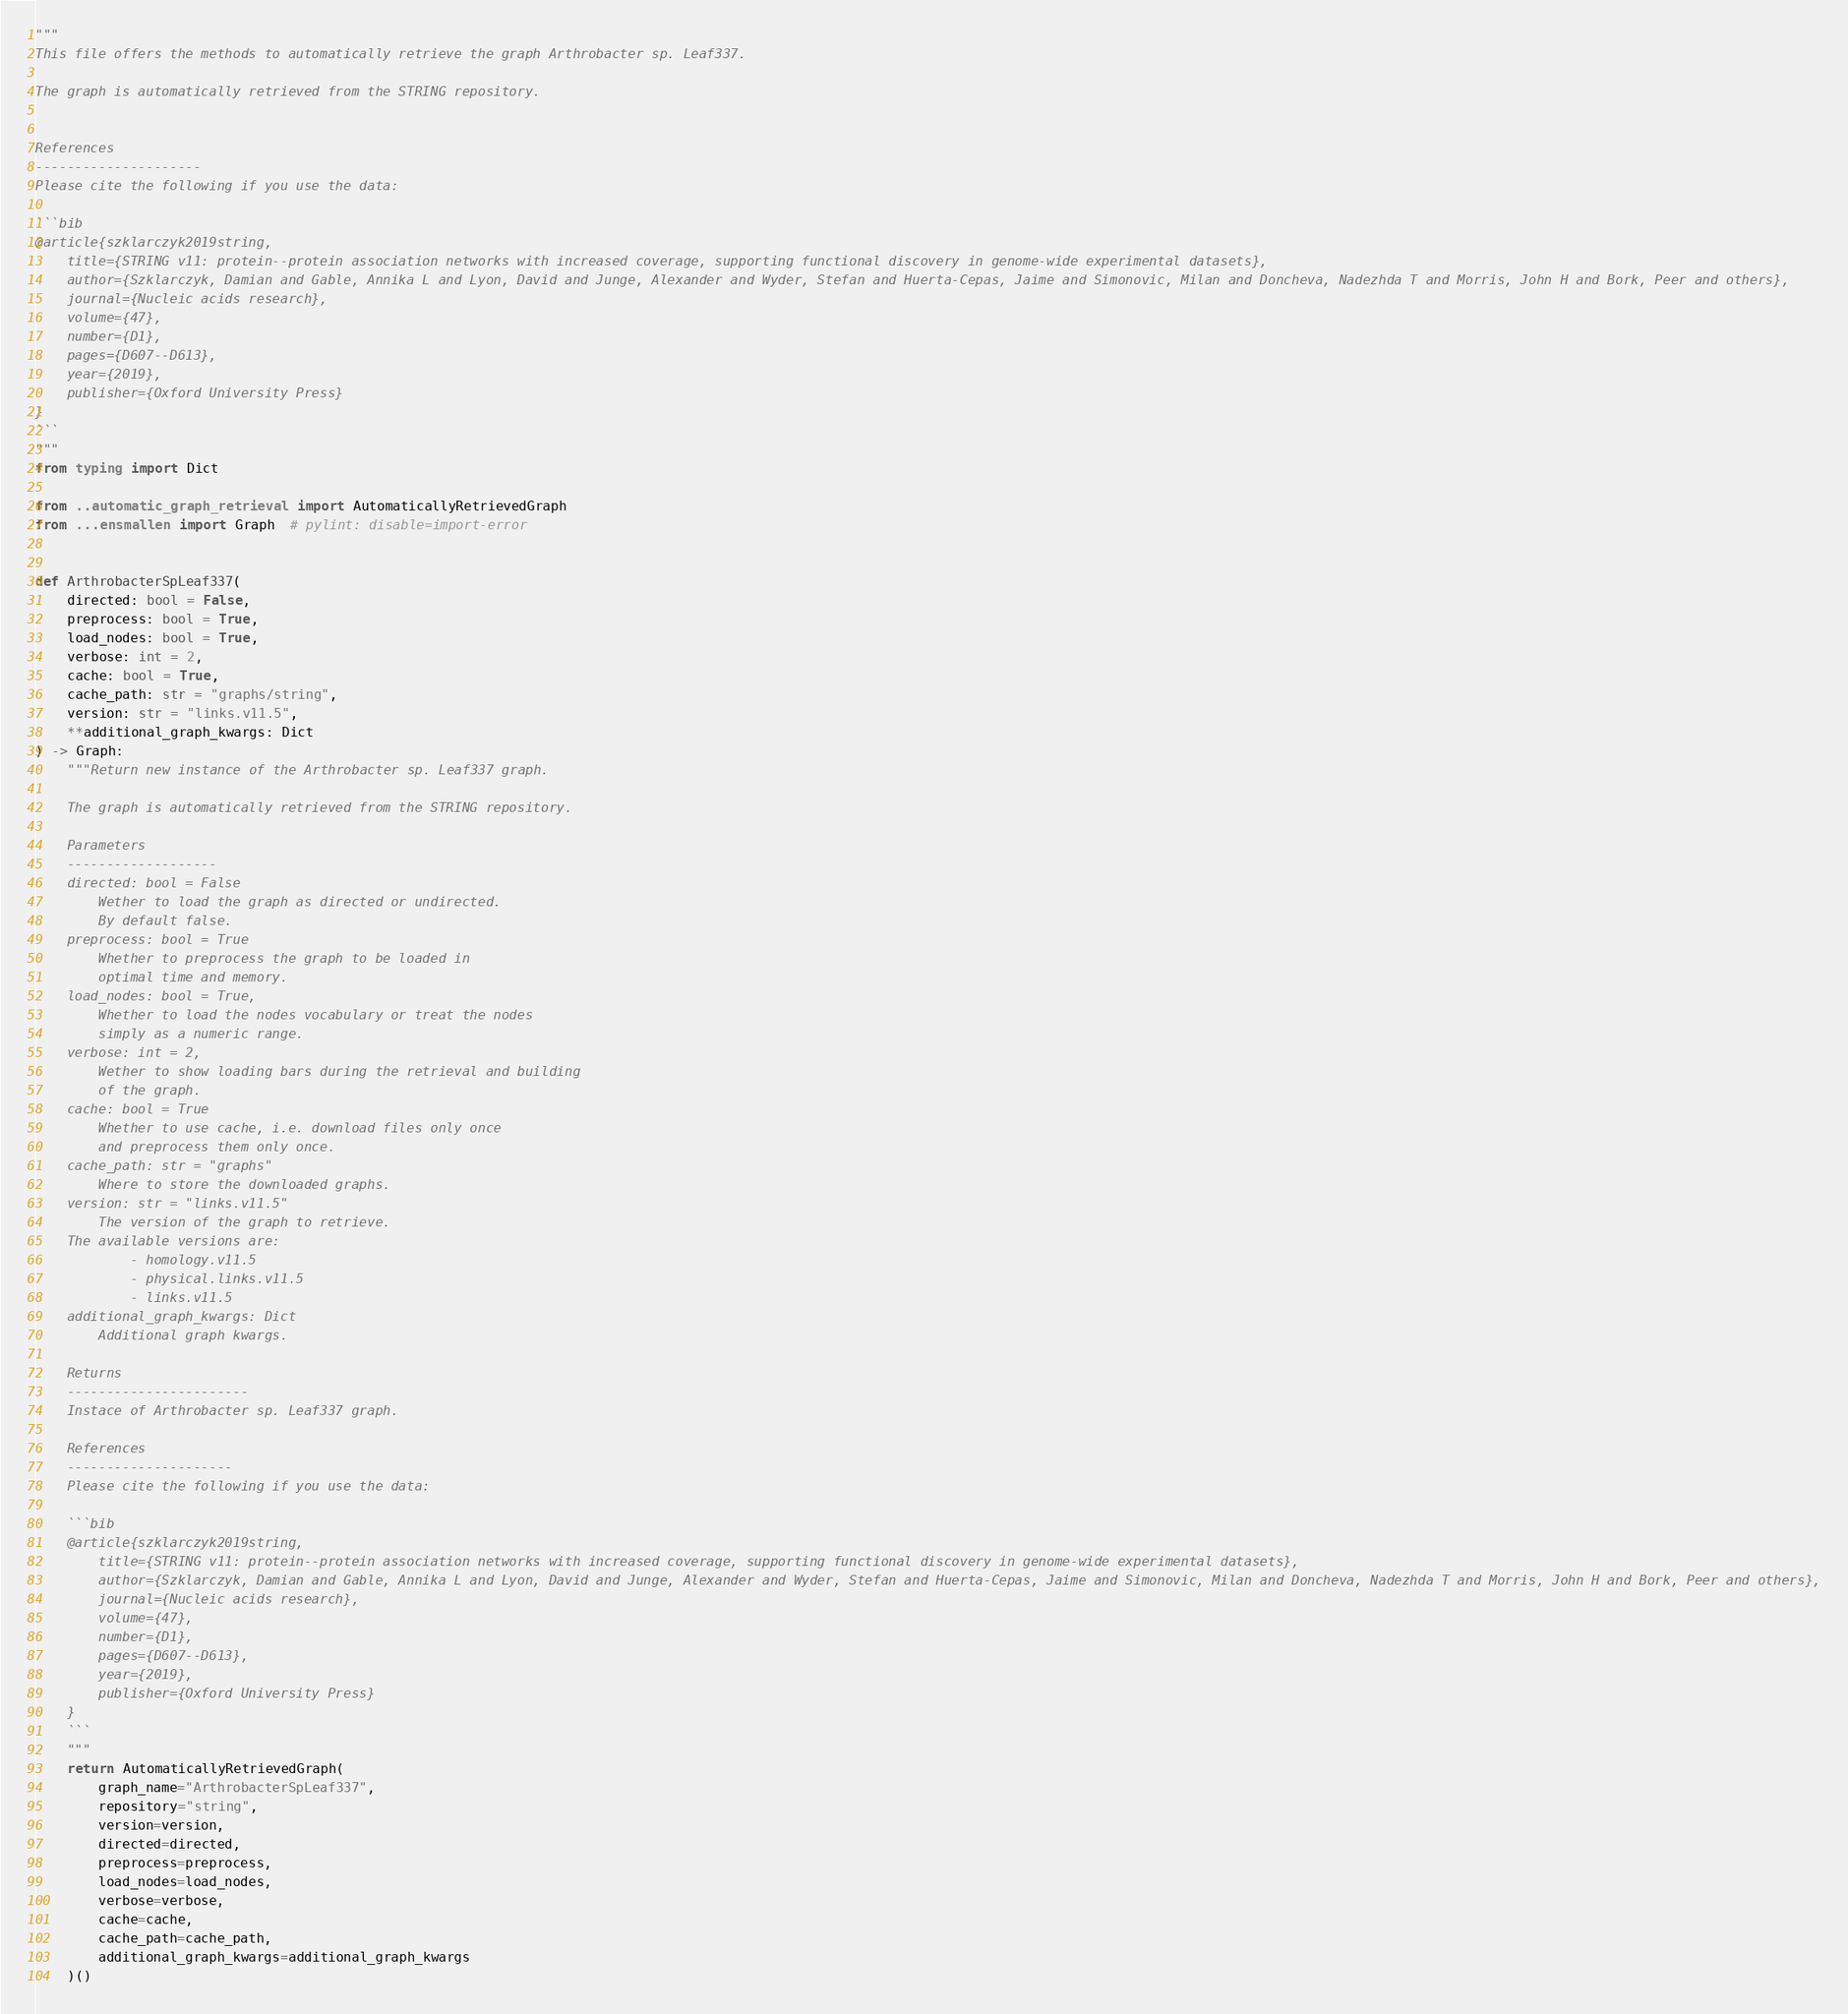<code> <loc_0><loc_0><loc_500><loc_500><_Python_>"""
This file offers the methods to automatically retrieve the graph Arthrobacter sp. Leaf337.

The graph is automatically retrieved from the STRING repository. 


References
---------------------
Please cite the following if you use the data:

```bib
@article{szklarczyk2019string,
    title={STRING v11: protein--protein association networks with increased coverage, supporting functional discovery in genome-wide experimental datasets},
    author={Szklarczyk, Damian and Gable, Annika L and Lyon, David and Junge, Alexander and Wyder, Stefan and Huerta-Cepas, Jaime and Simonovic, Milan and Doncheva, Nadezhda T and Morris, John H and Bork, Peer and others},
    journal={Nucleic acids research},
    volume={47},
    number={D1},
    pages={D607--D613},
    year={2019},
    publisher={Oxford University Press}
}
```
"""
from typing import Dict

from ..automatic_graph_retrieval import AutomaticallyRetrievedGraph
from ...ensmallen import Graph  # pylint: disable=import-error


def ArthrobacterSpLeaf337(
    directed: bool = False,
    preprocess: bool = True,
    load_nodes: bool = True,
    verbose: int = 2,
    cache: bool = True,
    cache_path: str = "graphs/string",
    version: str = "links.v11.5",
    **additional_graph_kwargs: Dict
) -> Graph:
    """Return new instance of the Arthrobacter sp. Leaf337 graph.

    The graph is automatically retrieved from the STRING repository.	

    Parameters
    -------------------
    directed: bool = False
        Wether to load the graph as directed or undirected.
        By default false.
    preprocess: bool = True
        Whether to preprocess the graph to be loaded in 
        optimal time and memory.
    load_nodes: bool = True,
        Whether to load the nodes vocabulary or treat the nodes
        simply as a numeric range.
    verbose: int = 2,
        Wether to show loading bars during the retrieval and building
        of the graph.
    cache: bool = True
        Whether to use cache, i.e. download files only once
        and preprocess them only once.
    cache_path: str = "graphs"
        Where to store the downloaded graphs.
    version: str = "links.v11.5"
        The version of the graph to retrieve.		
	The available versions are:
			- homology.v11.5
			- physical.links.v11.5
			- links.v11.5
    additional_graph_kwargs: Dict
        Additional graph kwargs.

    Returns
    -----------------------
    Instace of Arthrobacter sp. Leaf337 graph.

	References
	---------------------
	Please cite the following if you use the data:
	
	```bib
	@article{szklarczyk2019string,
	    title={STRING v11: protein--protein association networks with increased coverage, supporting functional discovery in genome-wide experimental datasets},
	    author={Szklarczyk, Damian and Gable, Annika L and Lyon, David and Junge, Alexander and Wyder, Stefan and Huerta-Cepas, Jaime and Simonovic, Milan and Doncheva, Nadezhda T and Morris, John H and Bork, Peer and others},
	    journal={Nucleic acids research},
	    volume={47},
	    number={D1},
	    pages={D607--D613},
	    year={2019},
	    publisher={Oxford University Press}
	}
	```
    """
    return AutomaticallyRetrievedGraph(
        graph_name="ArthrobacterSpLeaf337",
        repository="string",
        version=version,
        directed=directed,
        preprocess=preprocess,
        load_nodes=load_nodes,
        verbose=verbose,
        cache=cache,
        cache_path=cache_path,
        additional_graph_kwargs=additional_graph_kwargs
    )()
</code> 